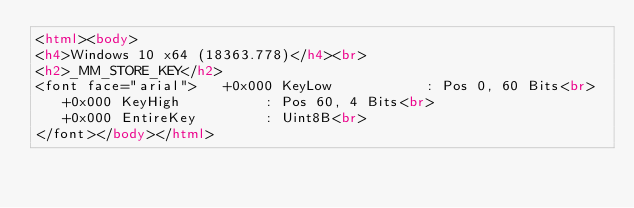<code> <loc_0><loc_0><loc_500><loc_500><_HTML_><html><body>
<h4>Windows 10 x64 (18363.778)</h4><br>
<h2>_MM_STORE_KEY</h2>
<font face="arial">   +0x000 KeyLow           : Pos 0, 60 Bits<br>
   +0x000 KeyHigh          : Pos 60, 4 Bits<br>
   +0x000 EntireKey        : Uint8B<br>
</font></body></html></code> 